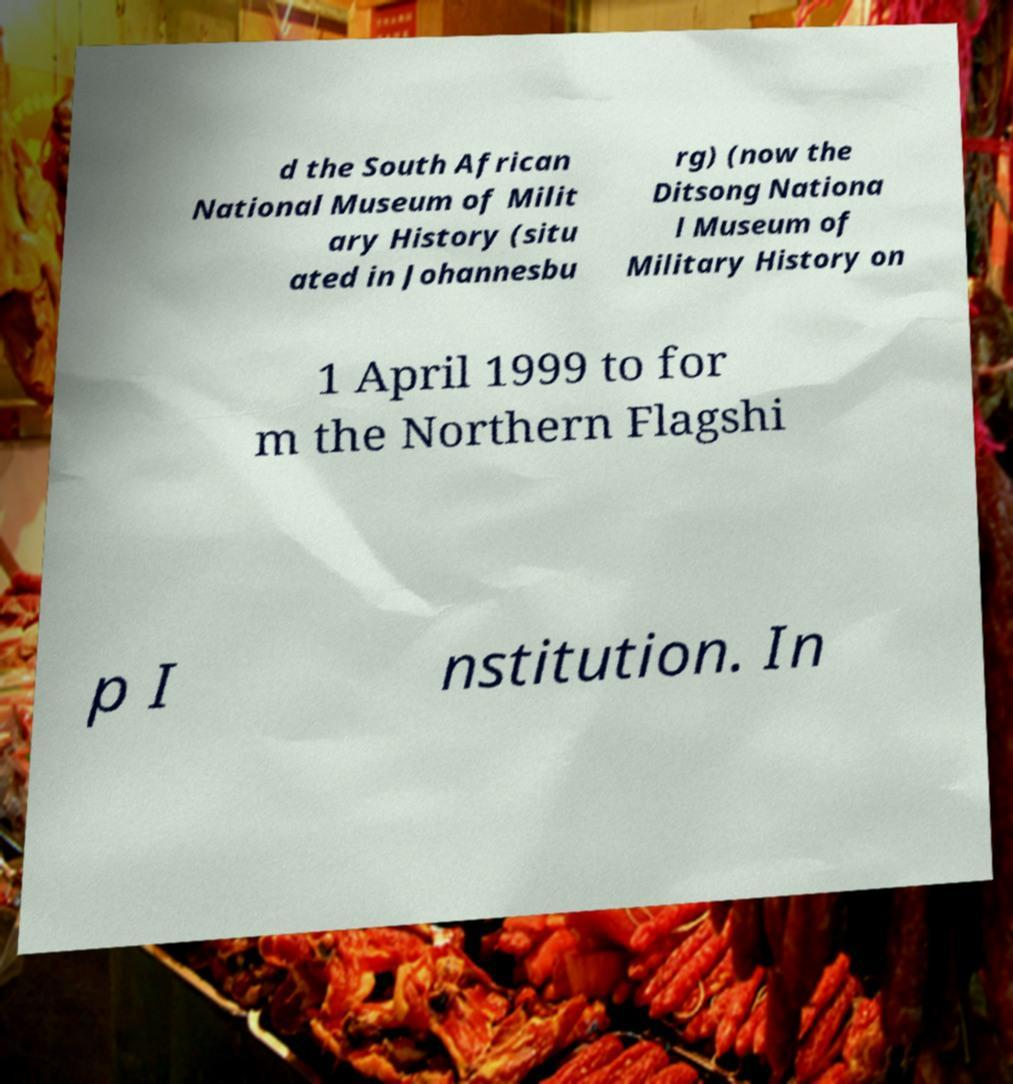Can you read and provide the text displayed in the image?This photo seems to have some interesting text. Can you extract and type it out for me? d the South African National Museum of Milit ary History (situ ated in Johannesbu rg) (now the Ditsong Nationa l Museum of Military History on 1 April 1999 to for m the Northern Flagshi p I nstitution. In 